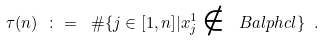Convert formula to latex. <formula><loc_0><loc_0><loc_500><loc_500>\tau ( n ) \ \colon = \ \# \{ j \in [ 1 , n ] | x ^ { 1 } _ { j } \notin \ B a l p h c l \} \ .</formula> 